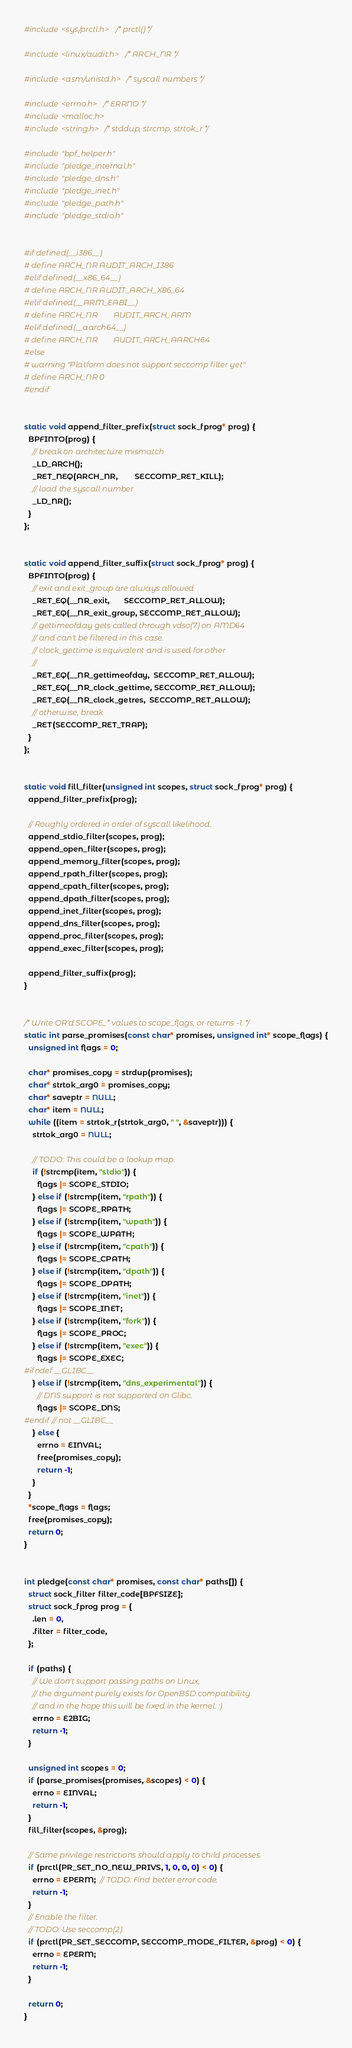Convert code to text. <code><loc_0><loc_0><loc_500><loc_500><_C_>#include <sys/prctl.h>  /* prctl() */

#include <linux/audit.h>  /* ARCH_NR */

#include <asm/unistd.h>  /* syscall numbers */

#include <errno.h>  /* ERRNO */
#include <malloc.h>
#include <string.h>  /* stddup, strcmp, strtok_r */

#include "bpf_helper.h"
#include "pledge_internal.h"
#include "pledge_dns.h"
#include "pledge_inet.h"
#include "pledge_path.h"
#include "pledge_stdio.h"


#if defined(__i386__)
# define ARCH_NR	AUDIT_ARCH_I386
#elif defined(__x86_64__)
# define ARCH_NR	AUDIT_ARCH_X86_64
#elif defined(__ARM_EABI__)
# define ARCH_NR        AUDIT_ARCH_ARM
#elif defined(__aarch64__)
# define ARCH_NR        AUDIT_ARCH_AARCH64
#else
# warning "Platform does not support seccomp filter yet"
# define ARCH_NR	0
#endif


static void append_filter_prefix(struct sock_fprog* prog) {
  BPFINTO(prog) {
    // break on architecture mismatch
    _LD_ARCH();
    _RET_NEQ(ARCH_NR,        SECCOMP_RET_KILL);
    // load the syscall number
    _LD_NR();
  }
};


static void append_filter_suffix(struct sock_fprog* prog) {
  BPFINTO(prog) {
    // exit and exit_group are always allowed
    _RET_EQ(__NR_exit,       SECCOMP_RET_ALLOW);
    _RET_EQ(__NR_exit_group, SECCOMP_RET_ALLOW);
    // gettimeofday gets called through vdso(7) on AMD64
    // and can't be filtered in this case.
    // clock_gettime is equivalent and is used for other
    //
    _RET_EQ(__NR_gettimeofday,  SECCOMP_RET_ALLOW);
    _RET_EQ(__NR_clock_gettime, SECCOMP_RET_ALLOW);
    _RET_EQ(__NR_clock_getres,  SECCOMP_RET_ALLOW);
    // otherwise, break
    _RET(SECCOMP_RET_TRAP);
  }
};


static void fill_filter(unsigned int scopes, struct sock_fprog* prog) {
  append_filter_prefix(prog);

  // Roughly ordered in order of syscall likelihood.
  append_stdio_filter(scopes, prog);
  append_open_filter(scopes, prog);
  append_memory_filter(scopes, prog);
  append_rpath_filter(scopes, prog);
  append_cpath_filter(scopes, prog);
  append_dpath_filter(scopes, prog);
  append_inet_filter(scopes, prog);
  append_dns_filter(scopes, prog);
  append_proc_filter(scopes, prog);
  append_exec_filter(scopes, prog);

  append_filter_suffix(prog);
}


/* Write OR'd SCOPE_* values to scope_flags, or returns -1. */
static int parse_promises(const char* promises, unsigned int* scope_flags) {
  unsigned int flags = 0;

  char* promises_copy = strdup(promises);
  char* strtok_arg0 = promises_copy;
  char* saveptr = NULL;
  char* item = NULL;
  while ((item = strtok_r(strtok_arg0, " ", &saveptr))) {
    strtok_arg0 = NULL;

    // TODO: This could be a lookup map.
    if (!strcmp(item, "stdio")) {
      flags |= SCOPE_STDIO;
    } else if (!strcmp(item, "rpath")) {
      flags |= SCOPE_RPATH;
    } else if (!strcmp(item, "wpath")) {
      flags |= SCOPE_WPATH;
    } else if (!strcmp(item, "cpath")) {
      flags |= SCOPE_CPATH;
    } else if (!strcmp(item, "dpath")) {
      flags |= SCOPE_DPATH;
    } else if (!strcmp(item, "inet")) {
      flags |= SCOPE_INET;
    } else if (!strcmp(item, "fork")) {
      flags |= SCOPE_PROC;
    } else if (!strcmp(item, "exec")) {
      flags |= SCOPE_EXEC;
#ifndef __GLIBC__
    } else if (!strcmp(item, "dns_experimental")) {
      // DNS support is not supported on Glibc.
      flags |= SCOPE_DNS;
#endif // not __GLIBC__
    } else {
      errno = EINVAL;
      free(promises_copy);
      return -1;
    }
  }
  *scope_flags = flags;
  free(promises_copy);
  return 0;
}


int pledge(const char* promises, const char* paths[]) {
  struct sock_filter filter_code[BPFSIZE];
  struct sock_fprog prog = {
    .len = 0,
    .filter = filter_code,
  };

  if (paths) {
    // We don't support passing paths on Linux,
    // the argument purely exists for OpenBSD compatibility
    // and in the hope this will be fixed in the kernel. :)
    errno = E2BIG;
    return -1;
  }

  unsigned int scopes = 0;
  if (parse_promises(promises, &scopes) < 0) {
    errno = EINVAL;
    return -1;
  }
  fill_filter(scopes, &prog);

  // Same privilege restrictions should apply to child processes.
  if (prctl(PR_SET_NO_NEW_PRIVS, 1, 0, 0, 0) < 0) {
    errno = EPERM;  // TODO: Find better error code.
    return -1;
  }
  // Enable the filter.
  // TODO: Use seccomp(2).
  if (prctl(PR_SET_SECCOMP, SECCOMP_MODE_FILTER, &prog) < 0) {
    errno = EPERM;
    return -1;
  }

  return 0;
}
</code> 